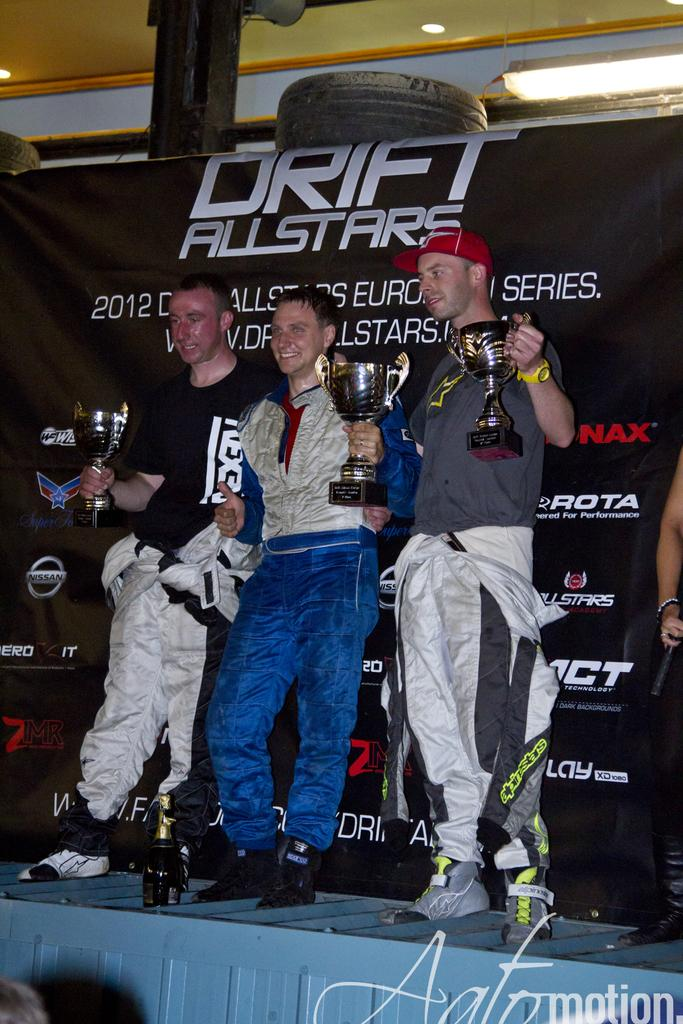Provide a one-sentence caption for the provided image. three guys holding trophies in front of banner for drift allstars. 